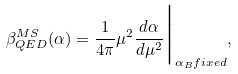<formula> <loc_0><loc_0><loc_500><loc_500>\beta _ { Q E D } ^ { M S } ( \alpha ) = \frac { 1 } { 4 \pi } \mu ^ { 2 } \frac { d \alpha } { d \mu ^ { 2 } } \Big | _ { \alpha _ { B } f i x e d } ,</formula> 